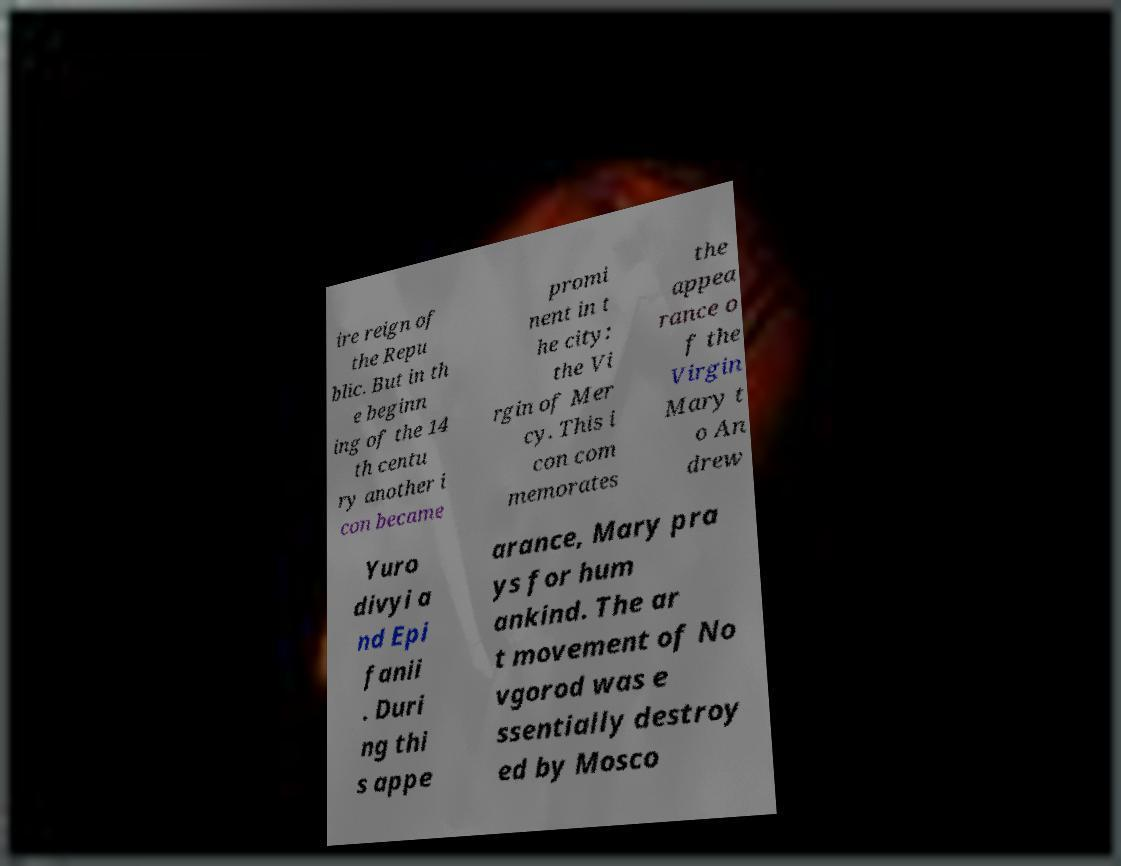What messages or text are displayed in this image? I need them in a readable, typed format. ire reign of the Repu blic. But in th e beginn ing of the 14 th centu ry another i con became promi nent in t he city: the Vi rgin of Mer cy. This i con com memorates the appea rance o f the Virgin Mary t o An drew Yuro divyi a nd Epi fanii . Duri ng thi s appe arance, Mary pra ys for hum ankind. The ar t movement of No vgorod was e ssentially destroy ed by Mosco 